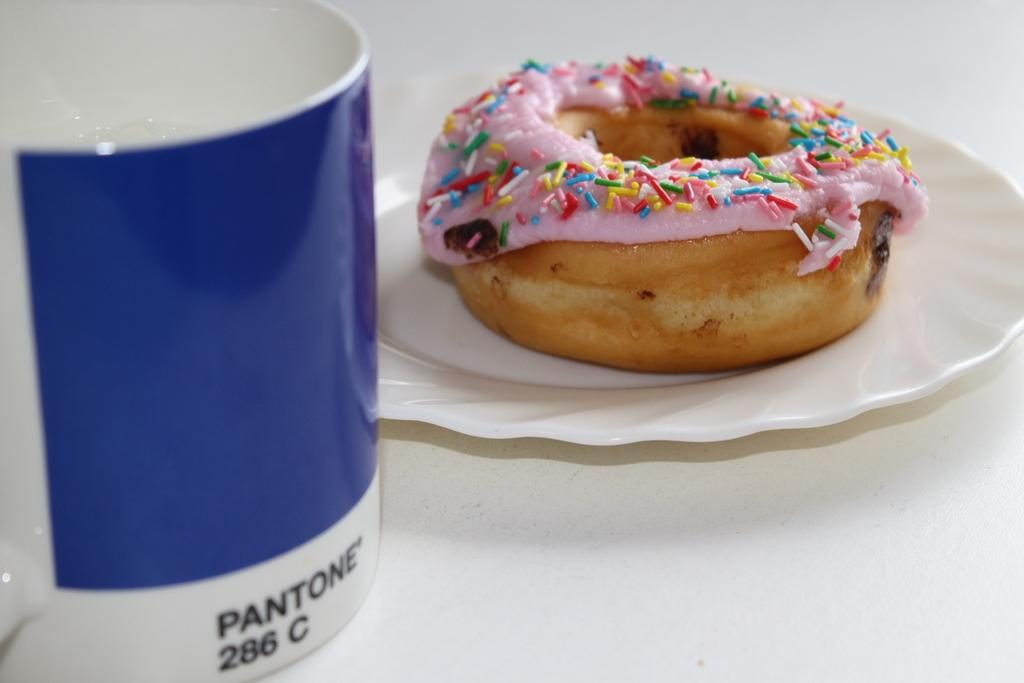What is on the plate in the image? There is food on a plate in the image. What else can be seen on the left side of the image? There is a cup on the left side of the image. What is written on the cup? The cup has text and numbers written on it. What type of flag is being waved by the crook in the image? There is no flag or crook present in the image. 